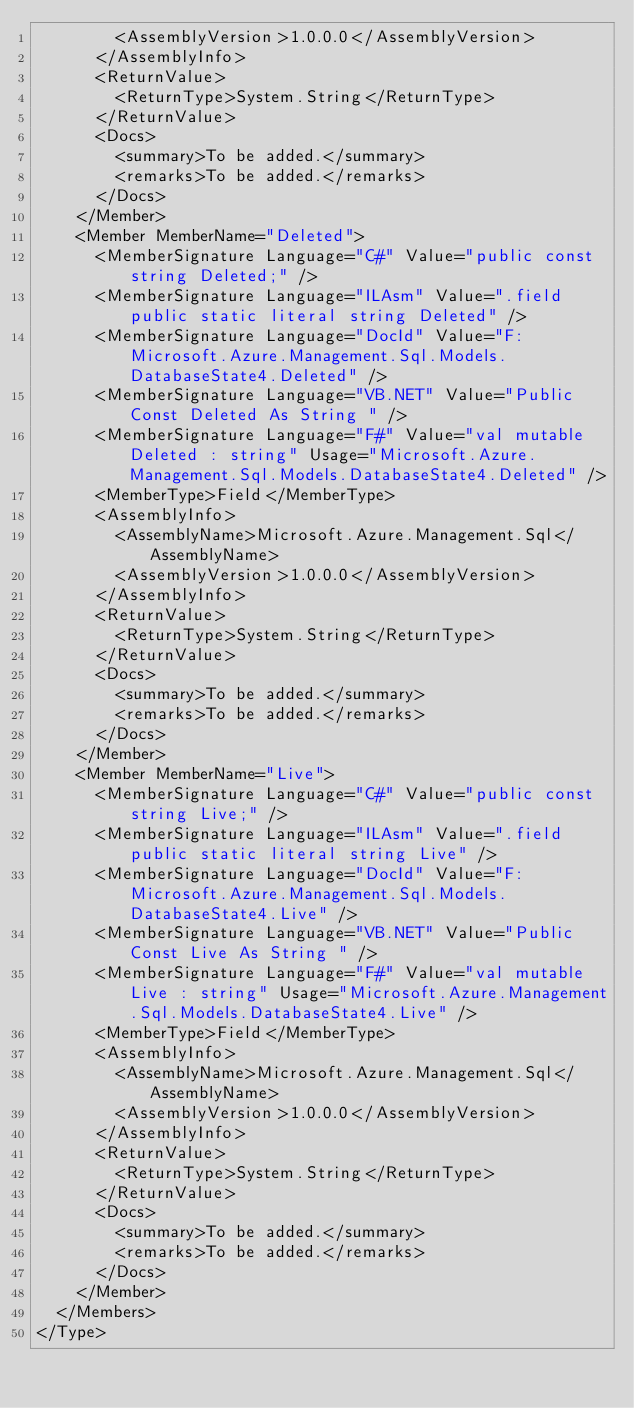<code> <loc_0><loc_0><loc_500><loc_500><_XML_>        <AssemblyVersion>1.0.0.0</AssemblyVersion>
      </AssemblyInfo>
      <ReturnValue>
        <ReturnType>System.String</ReturnType>
      </ReturnValue>
      <Docs>
        <summary>To be added.</summary>
        <remarks>To be added.</remarks>
      </Docs>
    </Member>
    <Member MemberName="Deleted">
      <MemberSignature Language="C#" Value="public const string Deleted;" />
      <MemberSignature Language="ILAsm" Value=".field public static literal string Deleted" />
      <MemberSignature Language="DocId" Value="F:Microsoft.Azure.Management.Sql.Models.DatabaseState4.Deleted" />
      <MemberSignature Language="VB.NET" Value="Public Const Deleted As String " />
      <MemberSignature Language="F#" Value="val mutable Deleted : string" Usage="Microsoft.Azure.Management.Sql.Models.DatabaseState4.Deleted" />
      <MemberType>Field</MemberType>
      <AssemblyInfo>
        <AssemblyName>Microsoft.Azure.Management.Sql</AssemblyName>
        <AssemblyVersion>1.0.0.0</AssemblyVersion>
      </AssemblyInfo>
      <ReturnValue>
        <ReturnType>System.String</ReturnType>
      </ReturnValue>
      <Docs>
        <summary>To be added.</summary>
        <remarks>To be added.</remarks>
      </Docs>
    </Member>
    <Member MemberName="Live">
      <MemberSignature Language="C#" Value="public const string Live;" />
      <MemberSignature Language="ILAsm" Value=".field public static literal string Live" />
      <MemberSignature Language="DocId" Value="F:Microsoft.Azure.Management.Sql.Models.DatabaseState4.Live" />
      <MemberSignature Language="VB.NET" Value="Public Const Live As String " />
      <MemberSignature Language="F#" Value="val mutable Live : string" Usage="Microsoft.Azure.Management.Sql.Models.DatabaseState4.Live" />
      <MemberType>Field</MemberType>
      <AssemblyInfo>
        <AssemblyName>Microsoft.Azure.Management.Sql</AssemblyName>
        <AssemblyVersion>1.0.0.0</AssemblyVersion>
      </AssemblyInfo>
      <ReturnValue>
        <ReturnType>System.String</ReturnType>
      </ReturnValue>
      <Docs>
        <summary>To be added.</summary>
        <remarks>To be added.</remarks>
      </Docs>
    </Member>
  </Members>
</Type>
</code> 